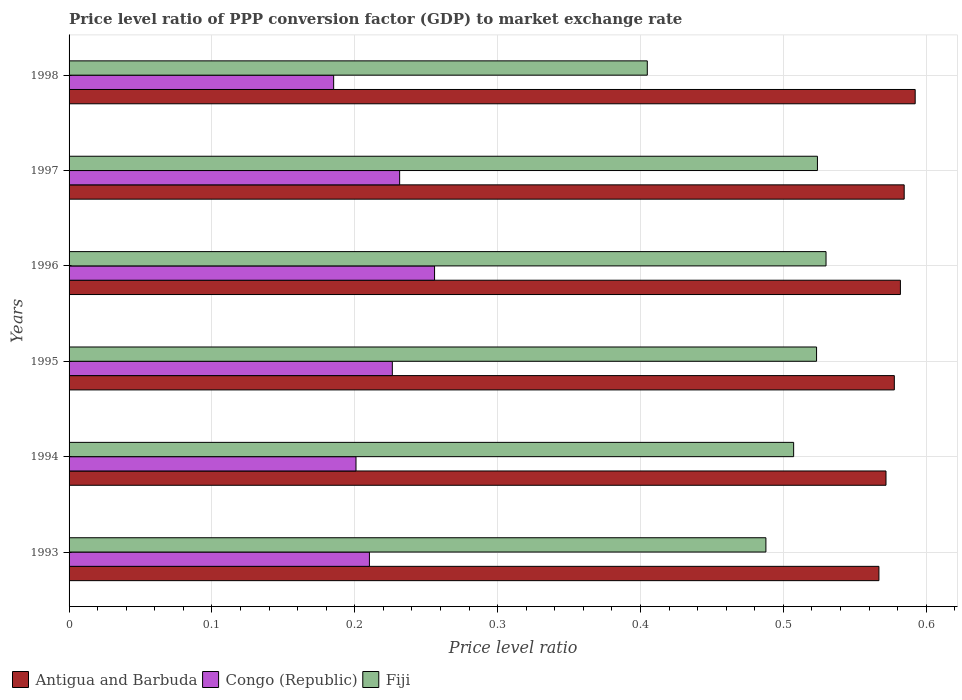How many different coloured bars are there?
Give a very brief answer. 3. Are the number of bars per tick equal to the number of legend labels?
Your answer should be very brief. Yes. Are the number of bars on each tick of the Y-axis equal?
Provide a short and direct response. Yes. How many bars are there on the 4th tick from the top?
Provide a short and direct response. 3. What is the price level ratio in Antigua and Barbuda in 1996?
Give a very brief answer. 0.58. Across all years, what is the maximum price level ratio in Antigua and Barbuda?
Your answer should be compact. 0.59. Across all years, what is the minimum price level ratio in Antigua and Barbuda?
Ensure brevity in your answer.  0.57. In which year was the price level ratio in Antigua and Barbuda minimum?
Give a very brief answer. 1993. What is the total price level ratio in Antigua and Barbuda in the graph?
Provide a succinct answer. 3.48. What is the difference between the price level ratio in Fiji in 1997 and that in 1998?
Your response must be concise. 0.12. What is the difference between the price level ratio in Antigua and Barbuda in 1998 and the price level ratio in Fiji in 1995?
Provide a short and direct response. 0.07. What is the average price level ratio in Fiji per year?
Provide a succinct answer. 0.5. In the year 1995, what is the difference between the price level ratio in Antigua and Barbuda and price level ratio in Fiji?
Offer a terse response. 0.05. In how many years, is the price level ratio in Congo (Republic) greater than 0.14 ?
Keep it short and to the point. 6. What is the ratio of the price level ratio in Fiji in 1993 to that in 1994?
Ensure brevity in your answer.  0.96. Is the price level ratio in Congo (Republic) in 1994 less than that in 1998?
Offer a terse response. No. Is the difference between the price level ratio in Antigua and Barbuda in 1995 and 1996 greater than the difference between the price level ratio in Fiji in 1995 and 1996?
Offer a terse response. Yes. What is the difference between the highest and the second highest price level ratio in Congo (Republic)?
Offer a terse response. 0.02. What is the difference between the highest and the lowest price level ratio in Congo (Republic)?
Offer a terse response. 0.07. Is the sum of the price level ratio in Antigua and Barbuda in 1993 and 1994 greater than the maximum price level ratio in Fiji across all years?
Provide a short and direct response. Yes. What does the 1st bar from the top in 1995 represents?
Keep it short and to the point. Fiji. What does the 1st bar from the bottom in 1996 represents?
Your response must be concise. Antigua and Barbuda. How many bars are there?
Offer a very short reply. 18. How many years are there in the graph?
Provide a succinct answer. 6. What is the difference between two consecutive major ticks on the X-axis?
Provide a succinct answer. 0.1. Does the graph contain any zero values?
Provide a short and direct response. No. How are the legend labels stacked?
Offer a terse response. Horizontal. What is the title of the graph?
Your answer should be compact. Price level ratio of PPP conversion factor (GDP) to market exchange rate. What is the label or title of the X-axis?
Keep it short and to the point. Price level ratio. What is the Price level ratio in Antigua and Barbuda in 1993?
Ensure brevity in your answer.  0.57. What is the Price level ratio in Congo (Republic) in 1993?
Provide a succinct answer. 0.21. What is the Price level ratio of Fiji in 1993?
Offer a terse response. 0.49. What is the Price level ratio in Antigua and Barbuda in 1994?
Make the answer very short. 0.57. What is the Price level ratio in Congo (Republic) in 1994?
Provide a short and direct response. 0.2. What is the Price level ratio of Fiji in 1994?
Keep it short and to the point. 0.51. What is the Price level ratio of Antigua and Barbuda in 1995?
Make the answer very short. 0.58. What is the Price level ratio of Congo (Republic) in 1995?
Offer a terse response. 0.23. What is the Price level ratio in Fiji in 1995?
Give a very brief answer. 0.52. What is the Price level ratio in Antigua and Barbuda in 1996?
Your answer should be compact. 0.58. What is the Price level ratio of Congo (Republic) in 1996?
Provide a succinct answer. 0.26. What is the Price level ratio in Fiji in 1996?
Provide a succinct answer. 0.53. What is the Price level ratio in Antigua and Barbuda in 1997?
Offer a terse response. 0.58. What is the Price level ratio in Congo (Republic) in 1997?
Your answer should be compact. 0.23. What is the Price level ratio in Fiji in 1997?
Provide a succinct answer. 0.52. What is the Price level ratio of Antigua and Barbuda in 1998?
Give a very brief answer. 0.59. What is the Price level ratio in Congo (Republic) in 1998?
Keep it short and to the point. 0.19. What is the Price level ratio in Fiji in 1998?
Give a very brief answer. 0.4. Across all years, what is the maximum Price level ratio in Antigua and Barbuda?
Your response must be concise. 0.59. Across all years, what is the maximum Price level ratio in Congo (Republic)?
Provide a succinct answer. 0.26. Across all years, what is the maximum Price level ratio in Fiji?
Your response must be concise. 0.53. Across all years, what is the minimum Price level ratio of Antigua and Barbuda?
Provide a short and direct response. 0.57. Across all years, what is the minimum Price level ratio in Congo (Republic)?
Your answer should be very brief. 0.19. Across all years, what is the minimum Price level ratio of Fiji?
Your response must be concise. 0.4. What is the total Price level ratio in Antigua and Barbuda in the graph?
Your response must be concise. 3.48. What is the total Price level ratio of Congo (Republic) in the graph?
Your answer should be very brief. 1.31. What is the total Price level ratio of Fiji in the graph?
Your answer should be very brief. 2.98. What is the difference between the Price level ratio in Antigua and Barbuda in 1993 and that in 1994?
Make the answer very short. -0.01. What is the difference between the Price level ratio in Congo (Republic) in 1993 and that in 1994?
Ensure brevity in your answer.  0.01. What is the difference between the Price level ratio in Fiji in 1993 and that in 1994?
Keep it short and to the point. -0.02. What is the difference between the Price level ratio of Antigua and Barbuda in 1993 and that in 1995?
Offer a very short reply. -0.01. What is the difference between the Price level ratio in Congo (Republic) in 1993 and that in 1995?
Your response must be concise. -0.02. What is the difference between the Price level ratio of Fiji in 1993 and that in 1995?
Your answer should be compact. -0.04. What is the difference between the Price level ratio in Antigua and Barbuda in 1993 and that in 1996?
Your response must be concise. -0.01. What is the difference between the Price level ratio in Congo (Republic) in 1993 and that in 1996?
Provide a succinct answer. -0.05. What is the difference between the Price level ratio of Fiji in 1993 and that in 1996?
Give a very brief answer. -0.04. What is the difference between the Price level ratio in Antigua and Barbuda in 1993 and that in 1997?
Your answer should be very brief. -0.02. What is the difference between the Price level ratio of Congo (Republic) in 1993 and that in 1997?
Your answer should be very brief. -0.02. What is the difference between the Price level ratio in Fiji in 1993 and that in 1997?
Your answer should be compact. -0.04. What is the difference between the Price level ratio in Antigua and Barbuda in 1993 and that in 1998?
Offer a terse response. -0.03. What is the difference between the Price level ratio in Congo (Republic) in 1993 and that in 1998?
Give a very brief answer. 0.03. What is the difference between the Price level ratio of Fiji in 1993 and that in 1998?
Your response must be concise. 0.08. What is the difference between the Price level ratio in Antigua and Barbuda in 1994 and that in 1995?
Ensure brevity in your answer.  -0.01. What is the difference between the Price level ratio in Congo (Republic) in 1994 and that in 1995?
Ensure brevity in your answer.  -0.03. What is the difference between the Price level ratio of Fiji in 1994 and that in 1995?
Make the answer very short. -0.02. What is the difference between the Price level ratio in Antigua and Barbuda in 1994 and that in 1996?
Provide a succinct answer. -0.01. What is the difference between the Price level ratio in Congo (Republic) in 1994 and that in 1996?
Make the answer very short. -0.06. What is the difference between the Price level ratio in Fiji in 1994 and that in 1996?
Your response must be concise. -0.02. What is the difference between the Price level ratio of Antigua and Barbuda in 1994 and that in 1997?
Keep it short and to the point. -0.01. What is the difference between the Price level ratio in Congo (Republic) in 1994 and that in 1997?
Give a very brief answer. -0.03. What is the difference between the Price level ratio in Fiji in 1994 and that in 1997?
Provide a succinct answer. -0.02. What is the difference between the Price level ratio of Antigua and Barbuda in 1994 and that in 1998?
Give a very brief answer. -0.02. What is the difference between the Price level ratio in Congo (Republic) in 1994 and that in 1998?
Your response must be concise. 0.02. What is the difference between the Price level ratio of Fiji in 1994 and that in 1998?
Your answer should be very brief. 0.1. What is the difference between the Price level ratio of Antigua and Barbuda in 1995 and that in 1996?
Provide a short and direct response. -0. What is the difference between the Price level ratio in Congo (Republic) in 1995 and that in 1996?
Provide a short and direct response. -0.03. What is the difference between the Price level ratio in Fiji in 1995 and that in 1996?
Offer a terse response. -0.01. What is the difference between the Price level ratio of Antigua and Barbuda in 1995 and that in 1997?
Your answer should be compact. -0.01. What is the difference between the Price level ratio of Congo (Republic) in 1995 and that in 1997?
Your answer should be compact. -0.01. What is the difference between the Price level ratio in Fiji in 1995 and that in 1997?
Keep it short and to the point. -0. What is the difference between the Price level ratio in Antigua and Barbuda in 1995 and that in 1998?
Offer a terse response. -0.01. What is the difference between the Price level ratio in Congo (Republic) in 1995 and that in 1998?
Give a very brief answer. 0.04. What is the difference between the Price level ratio in Fiji in 1995 and that in 1998?
Your answer should be compact. 0.12. What is the difference between the Price level ratio in Antigua and Barbuda in 1996 and that in 1997?
Make the answer very short. -0. What is the difference between the Price level ratio in Congo (Republic) in 1996 and that in 1997?
Your response must be concise. 0.02. What is the difference between the Price level ratio of Fiji in 1996 and that in 1997?
Ensure brevity in your answer.  0.01. What is the difference between the Price level ratio of Antigua and Barbuda in 1996 and that in 1998?
Provide a short and direct response. -0.01. What is the difference between the Price level ratio in Congo (Republic) in 1996 and that in 1998?
Offer a very short reply. 0.07. What is the difference between the Price level ratio of Fiji in 1996 and that in 1998?
Provide a short and direct response. 0.13. What is the difference between the Price level ratio of Antigua and Barbuda in 1997 and that in 1998?
Your response must be concise. -0.01. What is the difference between the Price level ratio in Congo (Republic) in 1997 and that in 1998?
Provide a short and direct response. 0.05. What is the difference between the Price level ratio in Fiji in 1997 and that in 1998?
Your answer should be very brief. 0.12. What is the difference between the Price level ratio in Antigua and Barbuda in 1993 and the Price level ratio in Congo (Republic) in 1994?
Your answer should be very brief. 0.37. What is the difference between the Price level ratio in Antigua and Barbuda in 1993 and the Price level ratio in Fiji in 1994?
Keep it short and to the point. 0.06. What is the difference between the Price level ratio in Congo (Republic) in 1993 and the Price level ratio in Fiji in 1994?
Make the answer very short. -0.3. What is the difference between the Price level ratio of Antigua and Barbuda in 1993 and the Price level ratio of Congo (Republic) in 1995?
Give a very brief answer. 0.34. What is the difference between the Price level ratio of Antigua and Barbuda in 1993 and the Price level ratio of Fiji in 1995?
Your answer should be compact. 0.04. What is the difference between the Price level ratio of Congo (Republic) in 1993 and the Price level ratio of Fiji in 1995?
Your answer should be compact. -0.31. What is the difference between the Price level ratio of Antigua and Barbuda in 1993 and the Price level ratio of Congo (Republic) in 1996?
Your answer should be compact. 0.31. What is the difference between the Price level ratio in Antigua and Barbuda in 1993 and the Price level ratio in Fiji in 1996?
Provide a short and direct response. 0.04. What is the difference between the Price level ratio in Congo (Republic) in 1993 and the Price level ratio in Fiji in 1996?
Give a very brief answer. -0.32. What is the difference between the Price level ratio in Antigua and Barbuda in 1993 and the Price level ratio in Congo (Republic) in 1997?
Keep it short and to the point. 0.34. What is the difference between the Price level ratio of Antigua and Barbuda in 1993 and the Price level ratio of Fiji in 1997?
Your response must be concise. 0.04. What is the difference between the Price level ratio in Congo (Republic) in 1993 and the Price level ratio in Fiji in 1997?
Your answer should be compact. -0.31. What is the difference between the Price level ratio of Antigua and Barbuda in 1993 and the Price level ratio of Congo (Republic) in 1998?
Provide a short and direct response. 0.38. What is the difference between the Price level ratio of Antigua and Barbuda in 1993 and the Price level ratio of Fiji in 1998?
Ensure brevity in your answer.  0.16. What is the difference between the Price level ratio in Congo (Republic) in 1993 and the Price level ratio in Fiji in 1998?
Provide a succinct answer. -0.19. What is the difference between the Price level ratio in Antigua and Barbuda in 1994 and the Price level ratio in Congo (Republic) in 1995?
Give a very brief answer. 0.35. What is the difference between the Price level ratio of Antigua and Barbuda in 1994 and the Price level ratio of Fiji in 1995?
Make the answer very short. 0.05. What is the difference between the Price level ratio in Congo (Republic) in 1994 and the Price level ratio in Fiji in 1995?
Give a very brief answer. -0.32. What is the difference between the Price level ratio in Antigua and Barbuda in 1994 and the Price level ratio in Congo (Republic) in 1996?
Give a very brief answer. 0.32. What is the difference between the Price level ratio of Antigua and Barbuda in 1994 and the Price level ratio of Fiji in 1996?
Provide a short and direct response. 0.04. What is the difference between the Price level ratio in Congo (Republic) in 1994 and the Price level ratio in Fiji in 1996?
Ensure brevity in your answer.  -0.33. What is the difference between the Price level ratio in Antigua and Barbuda in 1994 and the Price level ratio in Congo (Republic) in 1997?
Give a very brief answer. 0.34. What is the difference between the Price level ratio of Antigua and Barbuda in 1994 and the Price level ratio of Fiji in 1997?
Your response must be concise. 0.05. What is the difference between the Price level ratio in Congo (Republic) in 1994 and the Price level ratio in Fiji in 1997?
Offer a very short reply. -0.32. What is the difference between the Price level ratio of Antigua and Barbuda in 1994 and the Price level ratio of Congo (Republic) in 1998?
Make the answer very short. 0.39. What is the difference between the Price level ratio of Antigua and Barbuda in 1994 and the Price level ratio of Fiji in 1998?
Keep it short and to the point. 0.17. What is the difference between the Price level ratio in Congo (Republic) in 1994 and the Price level ratio in Fiji in 1998?
Make the answer very short. -0.2. What is the difference between the Price level ratio in Antigua and Barbuda in 1995 and the Price level ratio in Congo (Republic) in 1996?
Your response must be concise. 0.32. What is the difference between the Price level ratio of Antigua and Barbuda in 1995 and the Price level ratio of Fiji in 1996?
Ensure brevity in your answer.  0.05. What is the difference between the Price level ratio in Congo (Republic) in 1995 and the Price level ratio in Fiji in 1996?
Provide a succinct answer. -0.3. What is the difference between the Price level ratio in Antigua and Barbuda in 1995 and the Price level ratio in Congo (Republic) in 1997?
Provide a succinct answer. 0.35. What is the difference between the Price level ratio of Antigua and Barbuda in 1995 and the Price level ratio of Fiji in 1997?
Your response must be concise. 0.05. What is the difference between the Price level ratio of Congo (Republic) in 1995 and the Price level ratio of Fiji in 1997?
Give a very brief answer. -0.3. What is the difference between the Price level ratio in Antigua and Barbuda in 1995 and the Price level ratio in Congo (Republic) in 1998?
Offer a terse response. 0.39. What is the difference between the Price level ratio of Antigua and Barbuda in 1995 and the Price level ratio of Fiji in 1998?
Your response must be concise. 0.17. What is the difference between the Price level ratio in Congo (Republic) in 1995 and the Price level ratio in Fiji in 1998?
Make the answer very short. -0.18. What is the difference between the Price level ratio of Antigua and Barbuda in 1996 and the Price level ratio of Congo (Republic) in 1997?
Offer a very short reply. 0.35. What is the difference between the Price level ratio in Antigua and Barbuda in 1996 and the Price level ratio in Fiji in 1997?
Make the answer very short. 0.06. What is the difference between the Price level ratio in Congo (Republic) in 1996 and the Price level ratio in Fiji in 1997?
Provide a succinct answer. -0.27. What is the difference between the Price level ratio in Antigua and Barbuda in 1996 and the Price level ratio in Congo (Republic) in 1998?
Provide a succinct answer. 0.4. What is the difference between the Price level ratio in Antigua and Barbuda in 1996 and the Price level ratio in Fiji in 1998?
Give a very brief answer. 0.18. What is the difference between the Price level ratio in Congo (Republic) in 1996 and the Price level ratio in Fiji in 1998?
Your response must be concise. -0.15. What is the difference between the Price level ratio of Antigua and Barbuda in 1997 and the Price level ratio of Congo (Republic) in 1998?
Offer a very short reply. 0.4. What is the difference between the Price level ratio in Antigua and Barbuda in 1997 and the Price level ratio in Fiji in 1998?
Give a very brief answer. 0.18. What is the difference between the Price level ratio of Congo (Republic) in 1997 and the Price level ratio of Fiji in 1998?
Offer a terse response. -0.17. What is the average Price level ratio of Antigua and Barbuda per year?
Ensure brevity in your answer.  0.58. What is the average Price level ratio in Congo (Republic) per year?
Make the answer very short. 0.22. What is the average Price level ratio of Fiji per year?
Keep it short and to the point. 0.5. In the year 1993, what is the difference between the Price level ratio of Antigua and Barbuda and Price level ratio of Congo (Republic)?
Your answer should be very brief. 0.36. In the year 1993, what is the difference between the Price level ratio of Antigua and Barbuda and Price level ratio of Fiji?
Ensure brevity in your answer.  0.08. In the year 1993, what is the difference between the Price level ratio of Congo (Republic) and Price level ratio of Fiji?
Keep it short and to the point. -0.28. In the year 1994, what is the difference between the Price level ratio of Antigua and Barbuda and Price level ratio of Congo (Republic)?
Make the answer very short. 0.37. In the year 1994, what is the difference between the Price level ratio in Antigua and Barbuda and Price level ratio in Fiji?
Your answer should be very brief. 0.06. In the year 1994, what is the difference between the Price level ratio of Congo (Republic) and Price level ratio of Fiji?
Your response must be concise. -0.31. In the year 1995, what is the difference between the Price level ratio of Antigua and Barbuda and Price level ratio of Congo (Republic)?
Make the answer very short. 0.35. In the year 1995, what is the difference between the Price level ratio of Antigua and Barbuda and Price level ratio of Fiji?
Your answer should be very brief. 0.05. In the year 1995, what is the difference between the Price level ratio in Congo (Republic) and Price level ratio in Fiji?
Keep it short and to the point. -0.3. In the year 1996, what is the difference between the Price level ratio of Antigua and Barbuda and Price level ratio of Congo (Republic)?
Provide a succinct answer. 0.33. In the year 1996, what is the difference between the Price level ratio of Antigua and Barbuda and Price level ratio of Fiji?
Ensure brevity in your answer.  0.05. In the year 1996, what is the difference between the Price level ratio in Congo (Republic) and Price level ratio in Fiji?
Offer a very short reply. -0.27. In the year 1997, what is the difference between the Price level ratio in Antigua and Barbuda and Price level ratio in Congo (Republic)?
Provide a succinct answer. 0.35. In the year 1997, what is the difference between the Price level ratio in Antigua and Barbuda and Price level ratio in Fiji?
Offer a terse response. 0.06. In the year 1997, what is the difference between the Price level ratio in Congo (Republic) and Price level ratio in Fiji?
Make the answer very short. -0.29. In the year 1998, what is the difference between the Price level ratio in Antigua and Barbuda and Price level ratio in Congo (Republic)?
Your answer should be compact. 0.41. In the year 1998, what is the difference between the Price level ratio of Antigua and Barbuda and Price level ratio of Fiji?
Make the answer very short. 0.19. In the year 1998, what is the difference between the Price level ratio of Congo (Republic) and Price level ratio of Fiji?
Keep it short and to the point. -0.22. What is the ratio of the Price level ratio in Antigua and Barbuda in 1993 to that in 1994?
Provide a succinct answer. 0.99. What is the ratio of the Price level ratio of Congo (Republic) in 1993 to that in 1994?
Make the answer very short. 1.05. What is the ratio of the Price level ratio in Fiji in 1993 to that in 1994?
Keep it short and to the point. 0.96. What is the ratio of the Price level ratio of Antigua and Barbuda in 1993 to that in 1995?
Offer a very short reply. 0.98. What is the ratio of the Price level ratio of Congo (Republic) in 1993 to that in 1995?
Keep it short and to the point. 0.93. What is the ratio of the Price level ratio of Fiji in 1993 to that in 1995?
Your response must be concise. 0.93. What is the ratio of the Price level ratio in Antigua and Barbuda in 1993 to that in 1996?
Keep it short and to the point. 0.97. What is the ratio of the Price level ratio in Congo (Republic) in 1993 to that in 1996?
Your answer should be compact. 0.82. What is the ratio of the Price level ratio of Fiji in 1993 to that in 1996?
Give a very brief answer. 0.92. What is the ratio of the Price level ratio in Antigua and Barbuda in 1993 to that in 1997?
Offer a terse response. 0.97. What is the ratio of the Price level ratio of Congo (Republic) in 1993 to that in 1997?
Your answer should be compact. 0.91. What is the ratio of the Price level ratio in Fiji in 1993 to that in 1997?
Your answer should be compact. 0.93. What is the ratio of the Price level ratio in Antigua and Barbuda in 1993 to that in 1998?
Offer a terse response. 0.96. What is the ratio of the Price level ratio in Congo (Republic) in 1993 to that in 1998?
Provide a short and direct response. 1.14. What is the ratio of the Price level ratio in Fiji in 1993 to that in 1998?
Your answer should be compact. 1.21. What is the ratio of the Price level ratio in Congo (Republic) in 1994 to that in 1995?
Offer a terse response. 0.89. What is the ratio of the Price level ratio in Fiji in 1994 to that in 1995?
Give a very brief answer. 0.97. What is the ratio of the Price level ratio of Antigua and Barbuda in 1994 to that in 1996?
Give a very brief answer. 0.98. What is the ratio of the Price level ratio of Congo (Republic) in 1994 to that in 1996?
Offer a terse response. 0.79. What is the ratio of the Price level ratio of Fiji in 1994 to that in 1996?
Provide a short and direct response. 0.96. What is the ratio of the Price level ratio of Antigua and Barbuda in 1994 to that in 1997?
Your answer should be compact. 0.98. What is the ratio of the Price level ratio in Congo (Republic) in 1994 to that in 1997?
Offer a very short reply. 0.87. What is the ratio of the Price level ratio in Fiji in 1994 to that in 1997?
Your response must be concise. 0.97. What is the ratio of the Price level ratio of Antigua and Barbuda in 1994 to that in 1998?
Your response must be concise. 0.97. What is the ratio of the Price level ratio of Congo (Republic) in 1994 to that in 1998?
Offer a terse response. 1.08. What is the ratio of the Price level ratio of Fiji in 1994 to that in 1998?
Your response must be concise. 1.25. What is the ratio of the Price level ratio in Antigua and Barbuda in 1995 to that in 1996?
Provide a succinct answer. 0.99. What is the ratio of the Price level ratio of Congo (Republic) in 1995 to that in 1996?
Your answer should be compact. 0.88. What is the ratio of the Price level ratio of Fiji in 1995 to that in 1996?
Offer a terse response. 0.99. What is the ratio of the Price level ratio in Antigua and Barbuda in 1995 to that in 1997?
Your answer should be very brief. 0.99. What is the ratio of the Price level ratio in Congo (Republic) in 1995 to that in 1997?
Provide a short and direct response. 0.98. What is the ratio of the Price level ratio in Antigua and Barbuda in 1995 to that in 1998?
Your answer should be compact. 0.98. What is the ratio of the Price level ratio of Congo (Republic) in 1995 to that in 1998?
Your answer should be compact. 1.22. What is the ratio of the Price level ratio of Fiji in 1995 to that in 1998?
Your answer should be very brief. 1.29. What is the ratio of the Price level ratio in Congo (Republic) in 1996 to that in 1997?
Give a very brief answer. 1.11. What is the ratio of the Price level ratio in Fiji in 1996 to that in 1997?
Your answer should be very brief. 1.01. What is the ratio of the Price level ratio of Antigua and Barbuda in 1996 to that in 1998?
Provide a short and direct response. 0.98. What is the ratio of the Price level ratio of Congo (Republic) in 1996 to that in 1998?
Offer a very short reply. 1.38. What is the ratio of the Price level ratio in Fiji in 1996 to that in 1998?
Your answer should be compact. 1.31. What is the ratio of the Price level ratio of Antigua and Barbuda in 1997 to that in 1998?
Offer a terse response. 0.99. What is the ratio of the Price level ratio of Congo (Republic) in 1997 to that in 1998?
Give a very brief answer. 1.25. What is the ratio of the Price level ratio of Fiji in 1997 to that in 1998?
Provide a short and direct response. 1.29. What is the difference between the highest and the second highest Price level ratio in Antigua and Barbuda?
Offer a very short reply. 0.01. What is the difference between the highest and the second highest Price level ratio of Congo (Republic)?
Give a very brief answer. 0.02. What is the difference between the highest and the second highest Price level ratio of Fiji?
Your answer should be very brief. 0.01. What is the difference between the highest and the lowest Price level ratio in Antigua and Barbuda?
Give a very brief answer. 0.03. What is the difference between the highest and the lowest Price level ratio of Congo (Republic)?
Keep it short and to the point. 0.07. What is the difference between the highest and the lowest Price level ratio of Fiji?
Give a very brief answer. 0.13. 